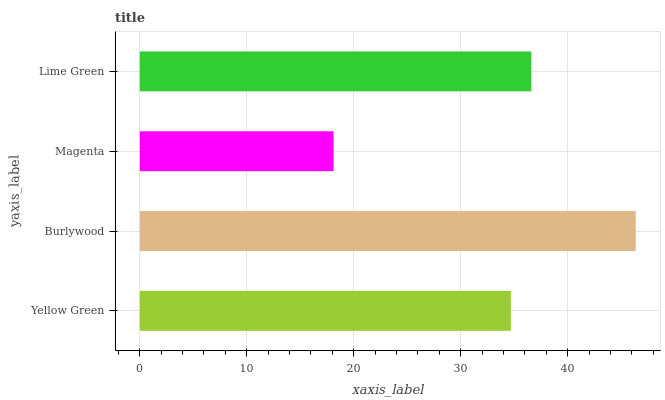Is Magenta the minimum?
Answer yes or no. Yes. Is Burlywood the maximum?
Answer yes or no. Yes. Is Burlywood the minimum?
Answer yes or no. No. Is Magenta the maximum?
Answer yes or no. No. Is Burlywood greater than Magenta?
Answer yes or no. Yes. Is Magenta less than Burlywood?
Answer yes or no. Yes. Is Magenta greater than Burlywood?
Answer yes or no. No. Is Burlywood less than Magenta?
Answer yes or no. No. Is Lime Green the high median?
Answer yes or no. Yes. Is Yellow Green the low median?
Answer yes or no. Yes. Is Yellow Green the high median?
Answer yes or no. No. Is Lime Green the low median?
Answer yes or no. No. 